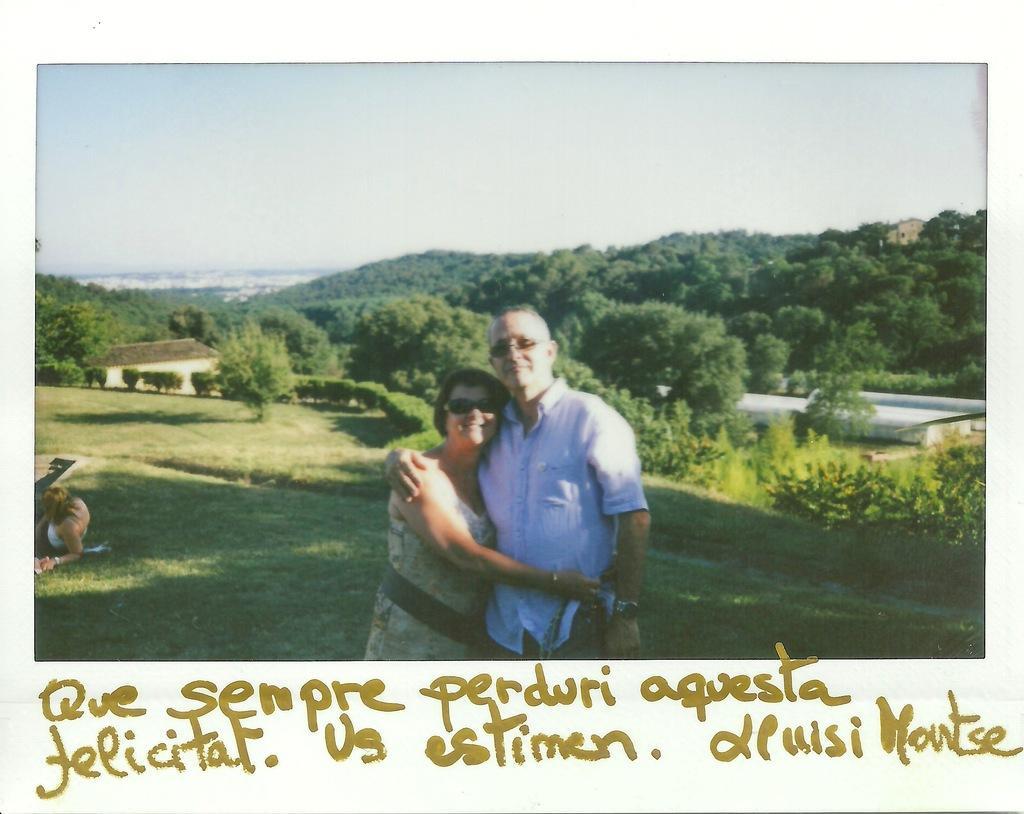In one or two sentences, can you explain what this image depicts? In this image in the middle there is a man and a woman. They both are wearing sunglasses. In the background there are trees, buildings. Here there is a lady. At the bottom some text are there. 